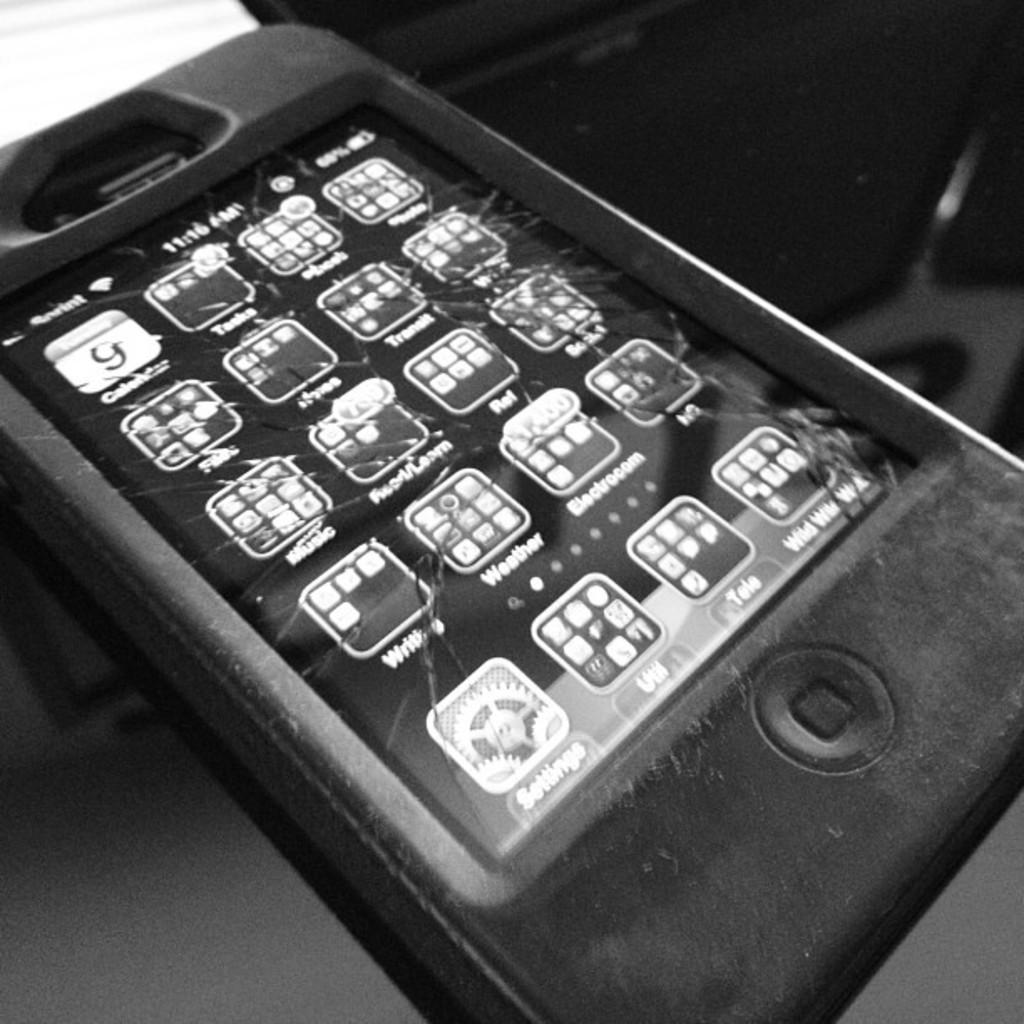<image>
Relay a brief, clear account of the picture shown. An iPhone in a thick case has a cracked screen and the first app says Calendar. 